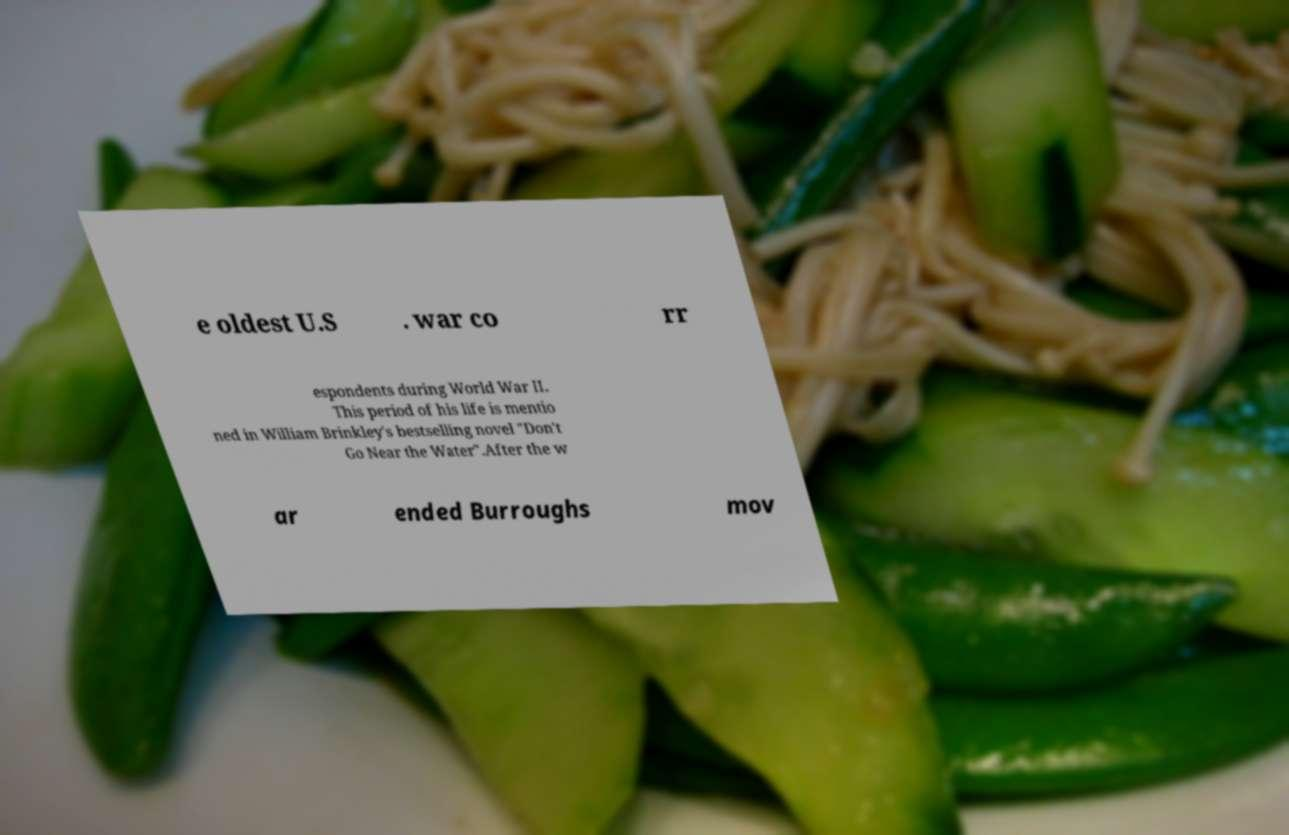I need the written content from this picture converted into text. Can you do that? e oldest U.S . war co rr espondents during World War II. This period of his life is mentio ned in William Brinkley's bestselling novel "Don't Go Near the Water".After the w ar ended Burroughs mov 